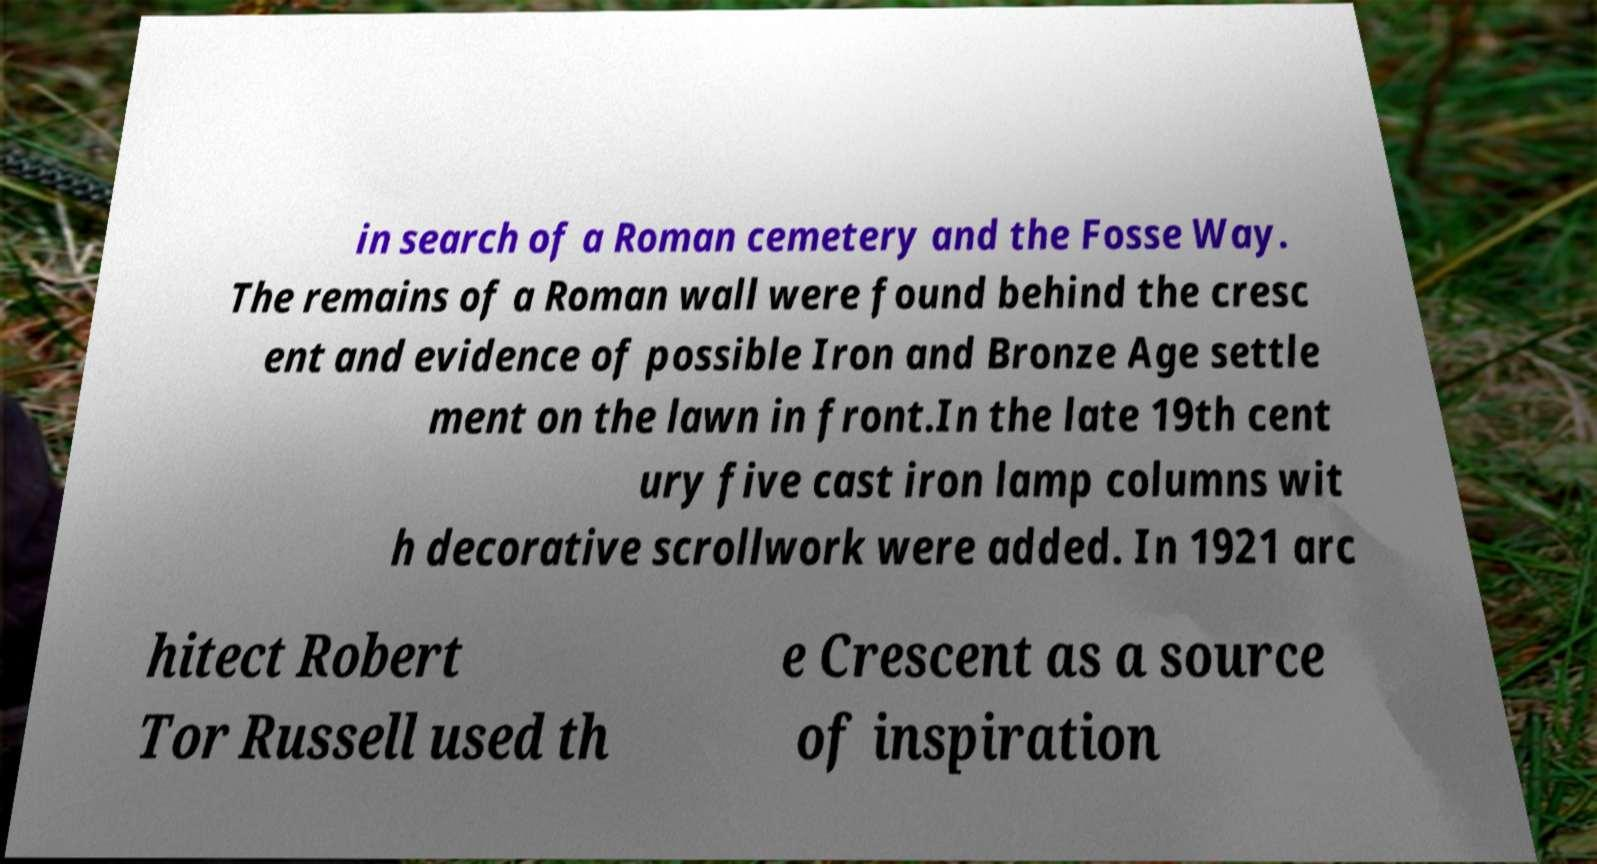Please identify and transcribe the text found in this image. in search of a Roman cemetery and the Fosse Way. The remains of a Roman wall were found behind the cresc ent and evidence of possible Iron and Bronze Age settle ment on the lawn in front.In the late 19th cent ury five cast iron lamp columns wit h decorative scrollwork were added. In 1921 arc hitect Robert Tor Russell used th e Crescent as a source of inspiration 